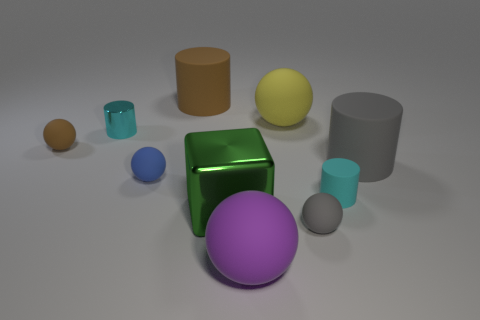What color is the large cylinder in front of the matte cylinder that is left of the big green metallic thing?
Give a very brief answer. Gray. What number of other objects are there of the same material as the small gray object?
Your answer should be very brief. 7. What number of cyan rubber cylinders are behind the small cyan thing that is to the right of the big brown rubber object?
Provide a succinct answer. 0. Is there anything else that has the same shape as the large green thing?
Your response must be concise. No. Is the color of the tiny cylinder to the right of the large green thing the same as the tiny cylinder behind the cyan rubber thing?
Provide a short and direct response. Yes. Is the number of big gray matte cylinders less than the number of yellow metal blocks?
Your answer should be compact. No. There is a large rubber object that is left of the sphere in front of the tiny gray sphere; what is its shape?
Your answer should be compact. Cylinder. What shape is the brown rubber thing that is to the left of the cyan thing that is left of the metal thing in front of the large gray matte object?
Provide a succinct answer. Sphere. What number of objects are spheres that are behind the cyan metallic cylinder or matte things that are to the left of the blue rubber thing?
Keep it short and to the point. 2. Does the shiny cylinder have the same size as the cyan thing on the right side of the green shiny cube?
Your answer should be compact. Yes. 